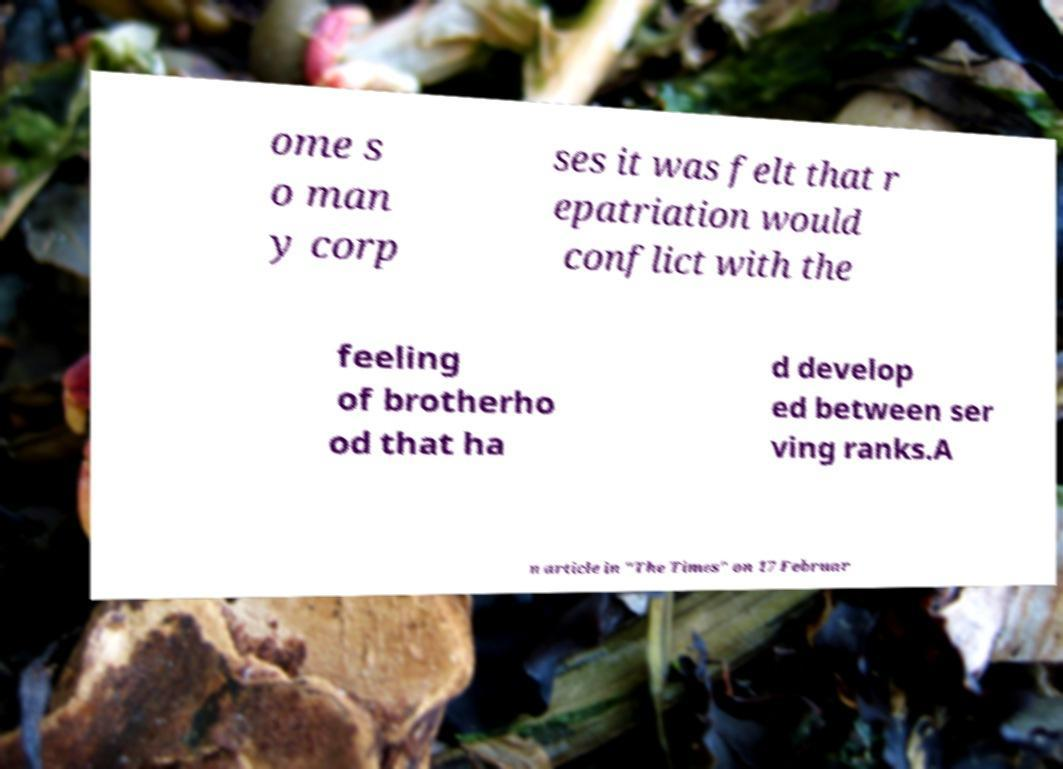For documentation purposes, I need the text within this image transcribed. Could you provide that? ome s o man y corp ses it was felt that r epatriation would conflict with the feeling of brotherho od that ha d develop ed between ser ving ranks.A n article in "The Times" on 17 Februar 